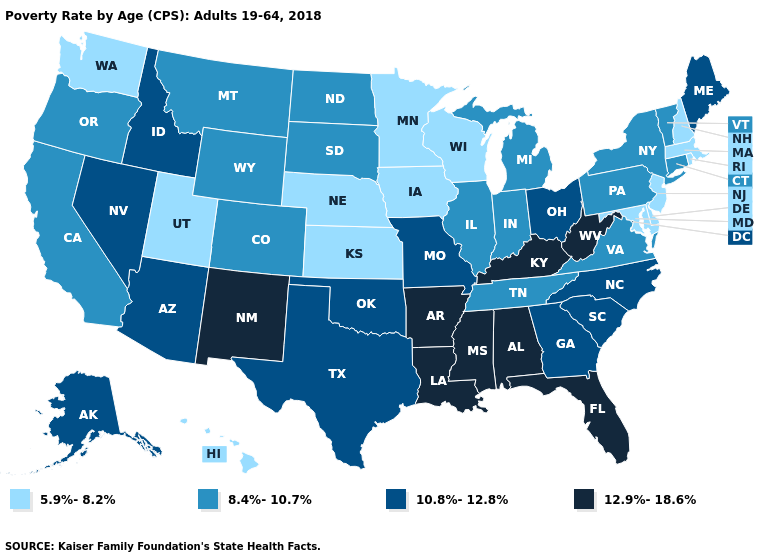Does Hawaii have a higher value than New York?
Give a very brief answer. No. What is the value of Indiana?
Quick response, please. 8.4%-10.7%. Is the legend a continuous bar?
Short answer required. No. Name the states that have a value in the range 5.9%-8.2%?
Keep it brief. Delaware, Hawaii, Iowa, Kansas, Maryland, Massachusetts, Minnesota, Nebraska, New Hampshire, New Jersey, Rhode Island, Utah, Washington, Wisconsin. Which states have the lowest value in the Northeast?
Write a very short answer. Massachusetts, New Hampshire, New Jersey, Rhode Island. Name the states that have a value in the range 10.8%-12.8%?
Give a very brief answer. Alaska, Arizona, Georgia, Idaho, Maine, Missouri, Nevada, North Carolina, Ohio, Oklahoma, South Carolina, Texas. Among the states that border Missouri , does Arkansas have the highest value?
Give a very brief answer. Yes. What is the value of Maryland?
Answer briefly. 5.9%-8.2%. What is the value of Texas?
Answer briefly. 10.8%-12.8%. What is the value of Alabama?
Write a very short answer. 12.9%-18.6%. Among the states that border Michigan , which have the highest value?
Quick response, please. Ohio. What is the value of Nevada?
Keep it brief. 10.8%-12.8%. What is the value of Oregon?
Be succinct. 8.4%-10.7%. Is the legend a continuous bar?
Give a very brief answer. No. Is the legend a continuous bar?
Give a very brief answer. No. 